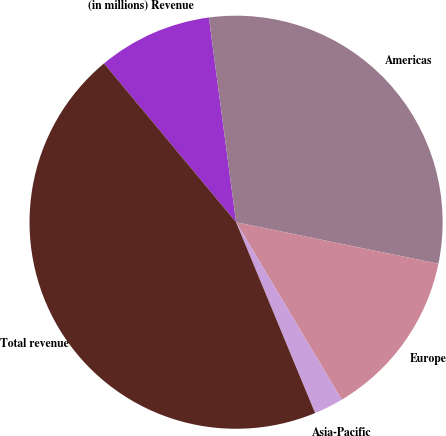Convert chart. <chart><loc_0><loc_0><loc_500><loc_500><pie_chart><fcel>(in millions) Revenue<fcel>Americas<fcel>Europe<fcel>Asia-Pacific<fcel>Total revenue<nl><fcel>8.94%<fcel>30.32%<fcel>13.23%<fcel>2.3%<fcel>45.2%<nl></chart> 